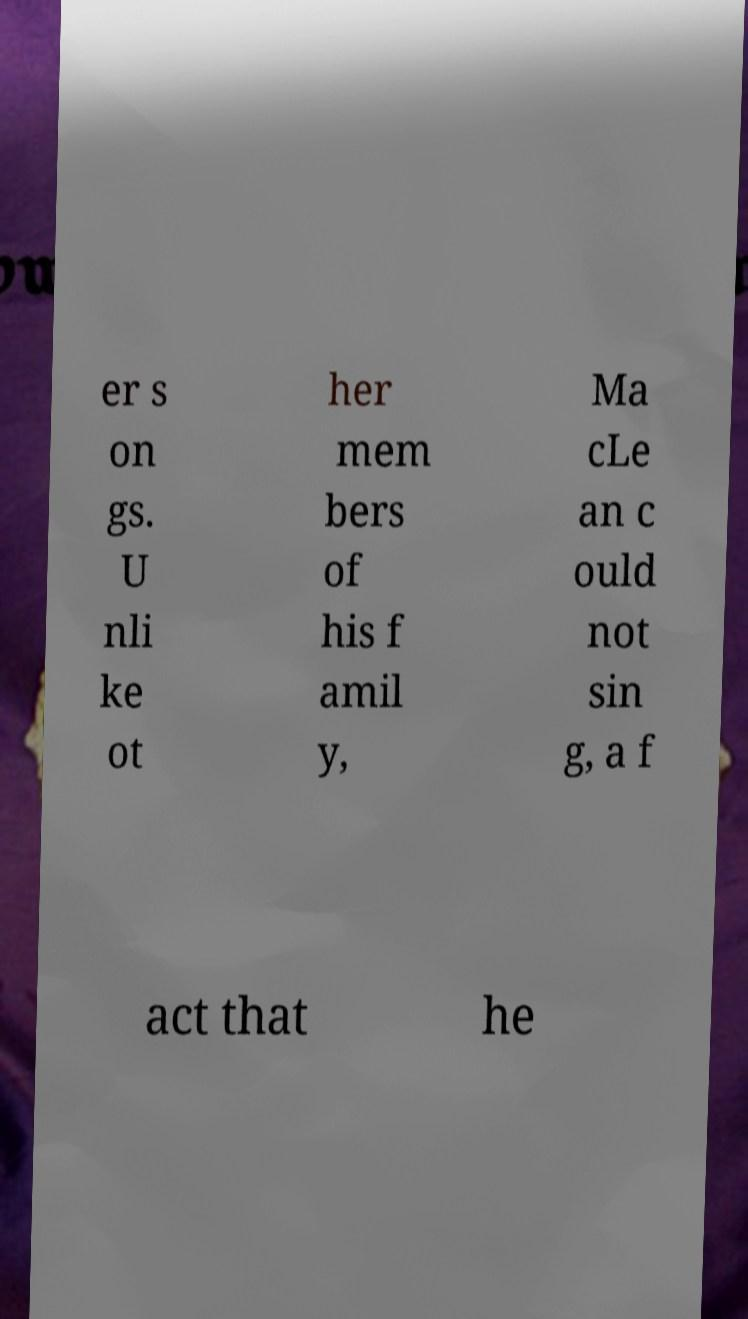Could you assist in decoding the text presented in this image and type it out clearly? er s on gs. U nli ke ot her mem bers of his f amil y, Ma cLe an c ould not sin g, a f act that he 